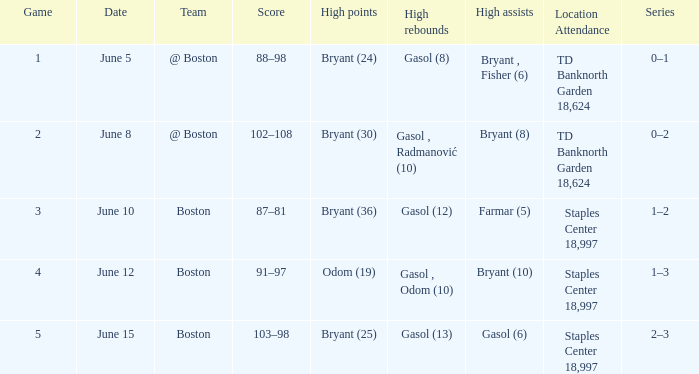Specify the site on june 1 Staples Center 18,997. 